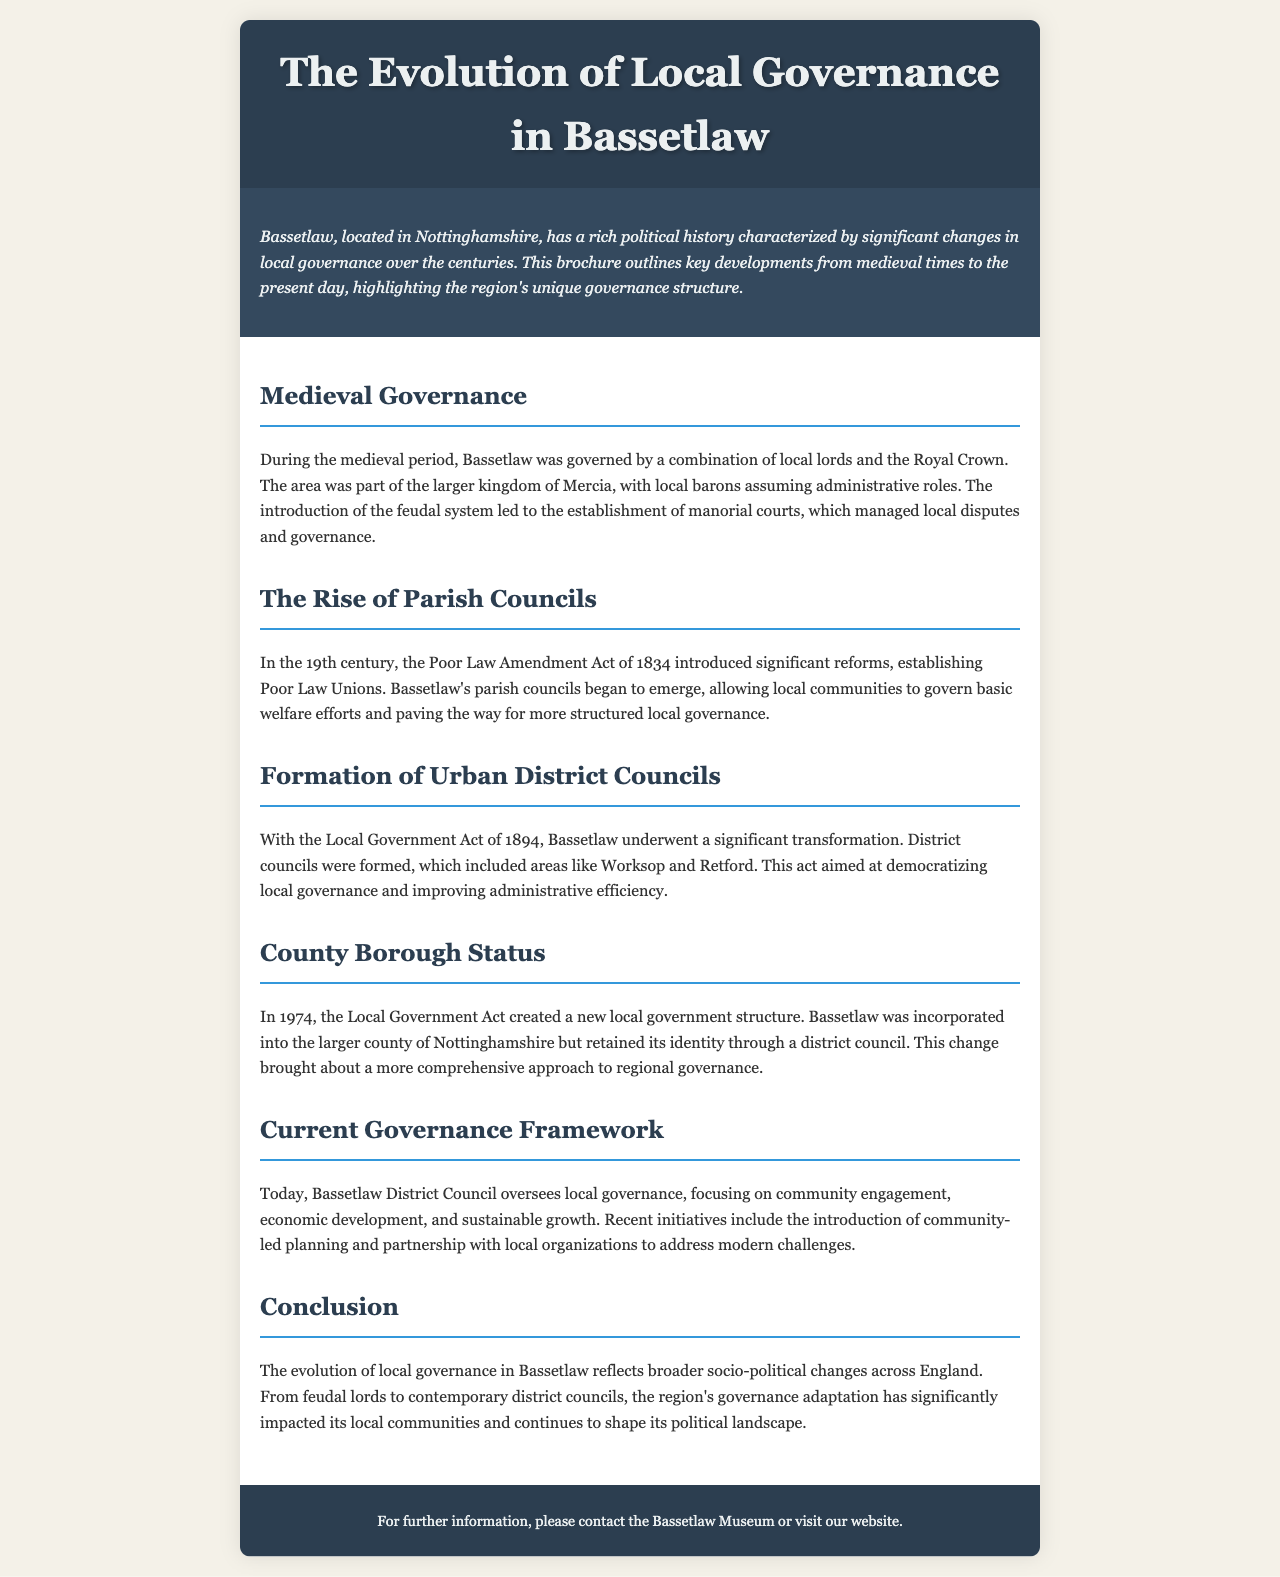What period did Bassetlaw have feudal governance? The document states that feudal governance was characteristic during the medieval period.
Answer: Medieval period What significant act introduced parish councils in Bassetlaw? The Poor Law Amendment Act of 1834 established parish councils in Bassetlaw.
Answer: Poor Law Amendment Act of 1834 Which act led to the formation of District Councils in Bassetlaw? The Local Government Act of 1894 was responsible for forming District Councils.
Answer: Local Government Act of 1894 When did Bassetlaw achieve County Borough status? The text indicates that Bassetlaw achieved County Borough status in 1974.
Answer: 1974 What is the primary focus of the current governance framework in Bassetlaw? The current focus is on community engagement, economic development, and sustainable growth.
Answer: Community engagement, economic development, and sustainable growth How did the governance in Bassetlaw evolve from the medieval period? The governance evolved from local lords and the Royal Crown to contemporary district councils.
Answer: From local lords and the Royal Crown to contemporary district councils What document type is this brochure classified as? The document is a brochure, which outlines local governance changes over centuries.
Answer: Brochure What is mentioned as a recent initiative by Bassetlaw District Council? The introduction of community-led planning is highlighted as a recent initiative.
Answer: Community-led planning 